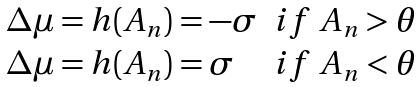<formula> <loc_0><loc_0><loc_500><loc_500>\begin{array} { l l } \Delta \mu = h ( A _ { n } ) = - \sigma & i f \ A _ { n } > \theta \\ \Delta \mu = h ( A _ { n } ) = \sigma & i f \ A _ { n } < \theta \\ \end{array}</formula> 